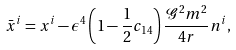<formula> <loc_0><loc_0><loc_500><loc_500>\bar { x } ^ { i } = x ^ { i } - \epsilon ^ { 4 } \left ( 1 - \frac { 1 } { 2 } c _ { 1 4 } \right ) \frac { \mathcal { G } ^ { 2 } m ^ { 2 } } { 4 r } n ^ { i } ,</formula> 